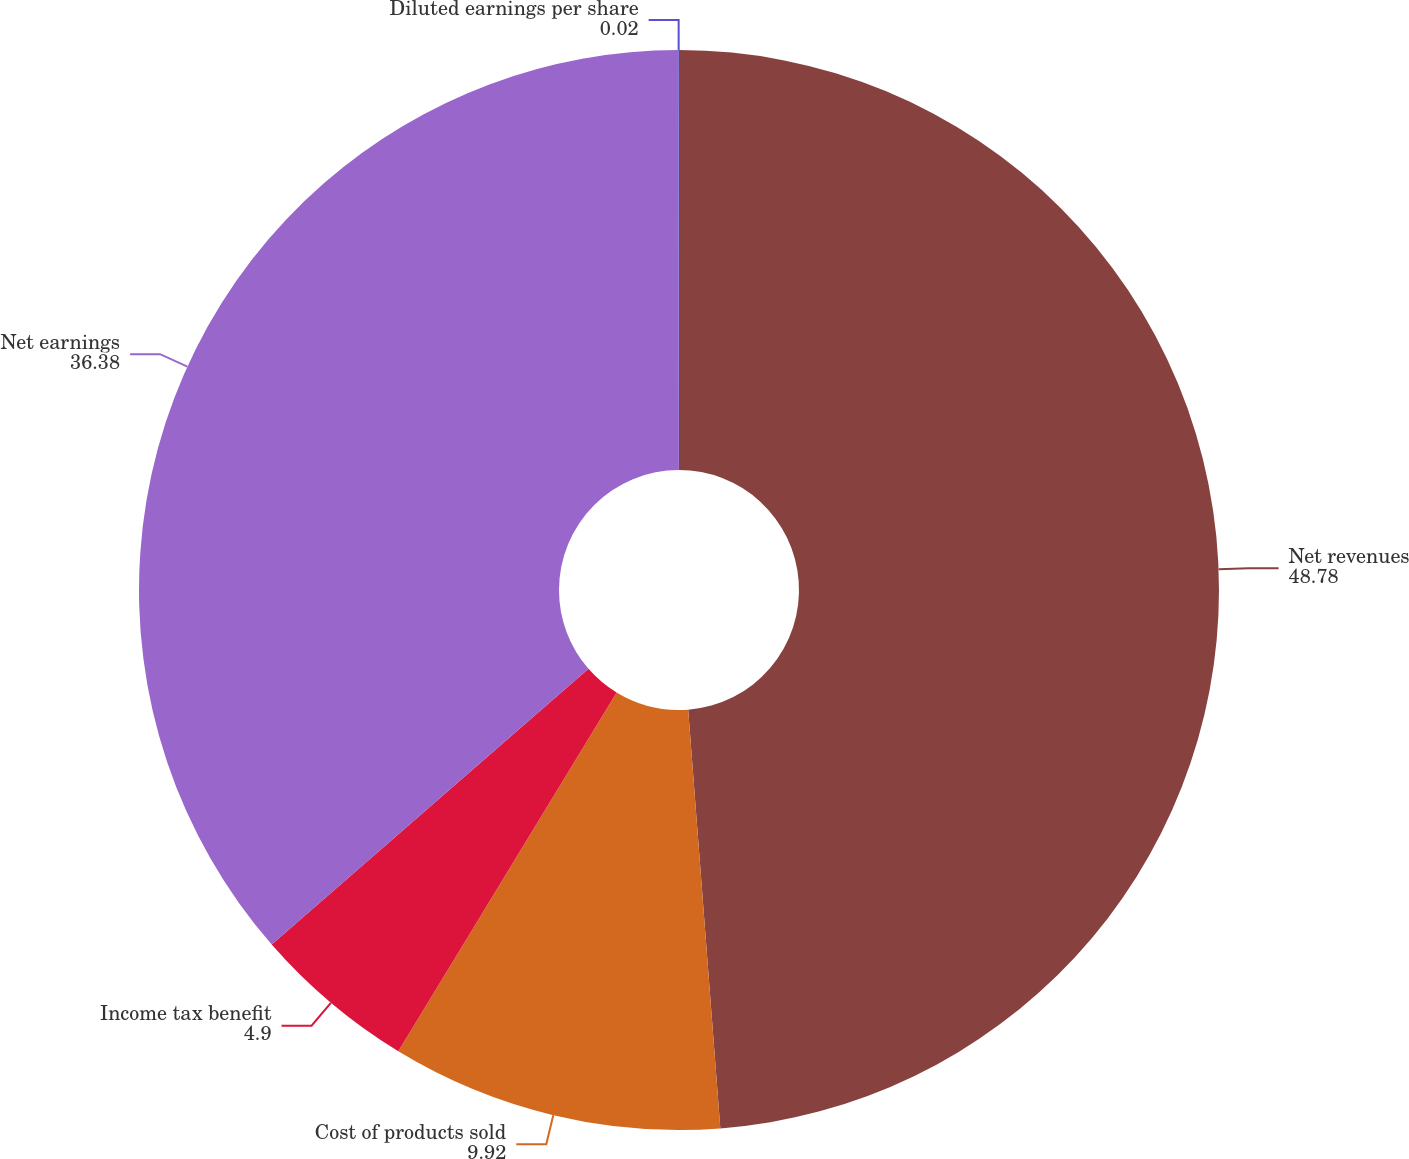<chart> <loc_0><loc_0><loc_500><loc_500><pie_chart><fcel>Net revenues<fcel>Cost of products sold<fcel>Income tax benefit<fcel>Net earnings<fcel>Diluted earnings per share<nl><fcel>48.78%<fcel>9.92%<fcel>4.9%<fcel>36.38%<fcel>0.02%<nl></chart> 